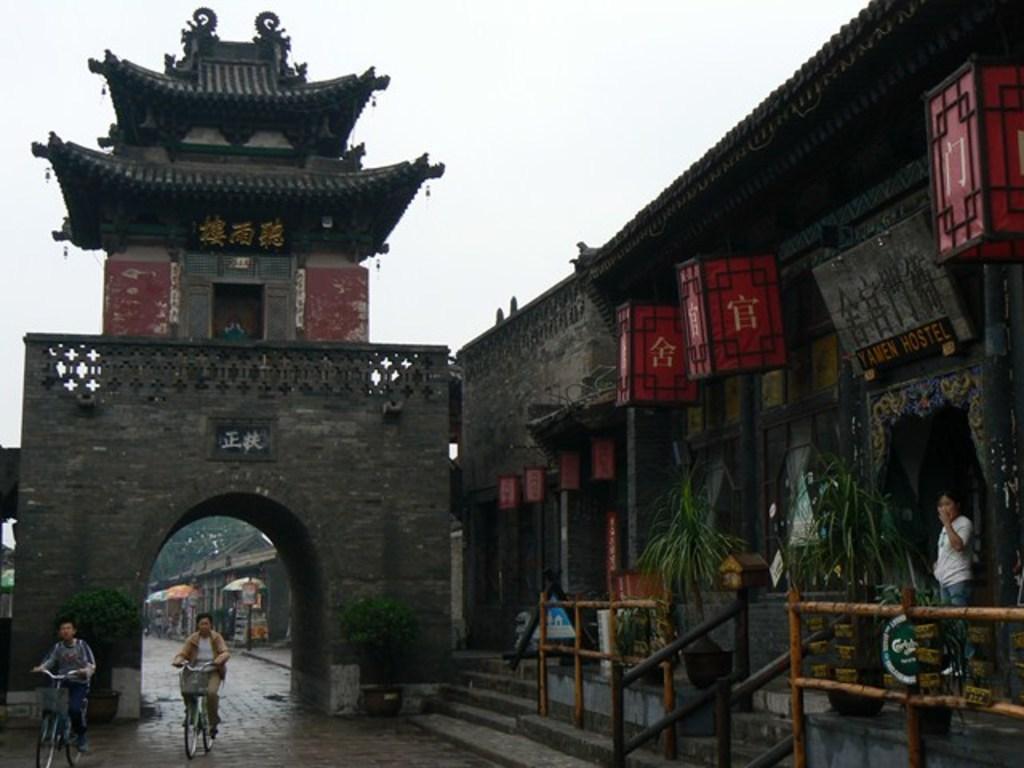How would you summarize this image in a sentence or two? In this image, we can see an arch, at the right side there is a building, at the left side there are two persons riding the bicycles, at the top there is a sky which is cloudy. 